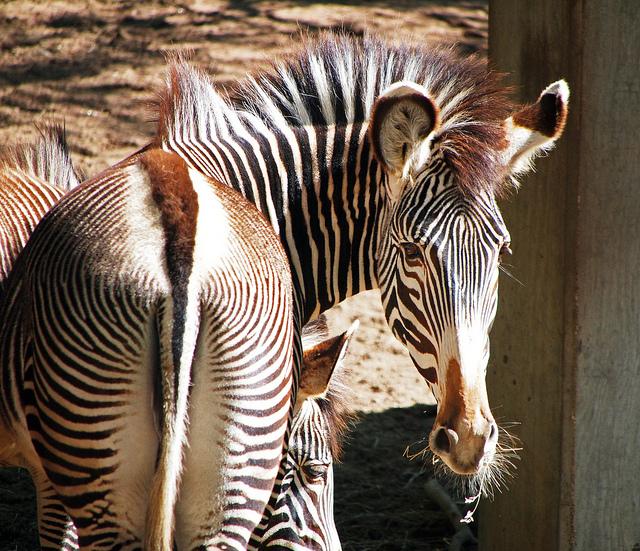Is the main zebra looking towards the photographer?
Concise answer only. Yes. Are the stripes even on both sides?
Concise answer only. Yes. Does the zebra have whiskers?
Write a very short answer. Yes. 